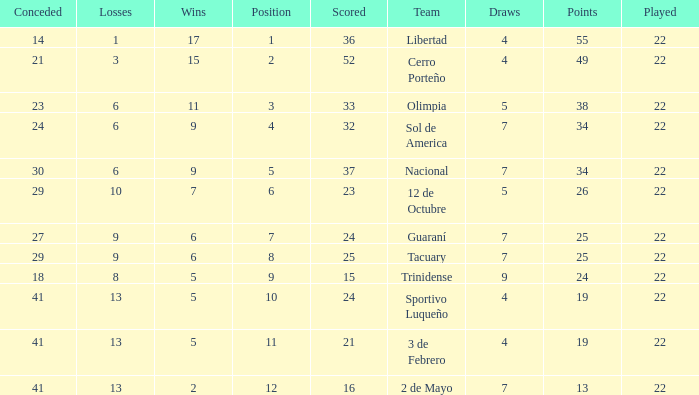What is the fewest wins that has fewer than 23 goals scored, team of 2 de Mayo, and fewer than 7 draws? None. 